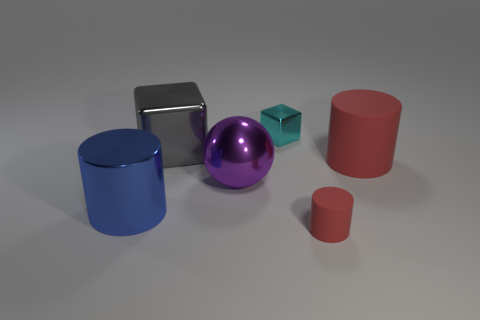There is a tiny cylinder that is the same color as the large rubber cylinder; what material is it?
Give a very brief answer. Rubber. There is a metallic object that is on the right side of the large purple metallic sphere; what is its size?
Provide a short and direct response. Small. What size is the rubber cylinder that is in front of the large shiny thing on the right side of the big gray metal thing?
Keep it short and to the point. Small. The big shiny object to the left of the big metallic object behind the red matte thing that is to the right of the tiny red rubber object is what shape?
Provide a succinct answer. Cylinder. Does the small object that is in front of the big red matte object have the same color as the big cylinder to the right of the small cyan shiny object?
Make the answer very short. Yes. How many large purple metal cubes are there?
Provide a succinct answer. 0. There is a big gray shiny cube; are there any things behind it?
Offer a terse response. Yes. Are the cylinder that is behind the blue metallic thing and the big object that is behind the big red thing made of the same material?
Ensure brevity in your answer.  No. Is the number of large blocks that are to the right of the blue thing less than the number of big gray blocks?
Keep it short and to the point. No. There is a tiny object behind the large gray metallic object; what color is it?
Give a very brief answer. Cyan. 